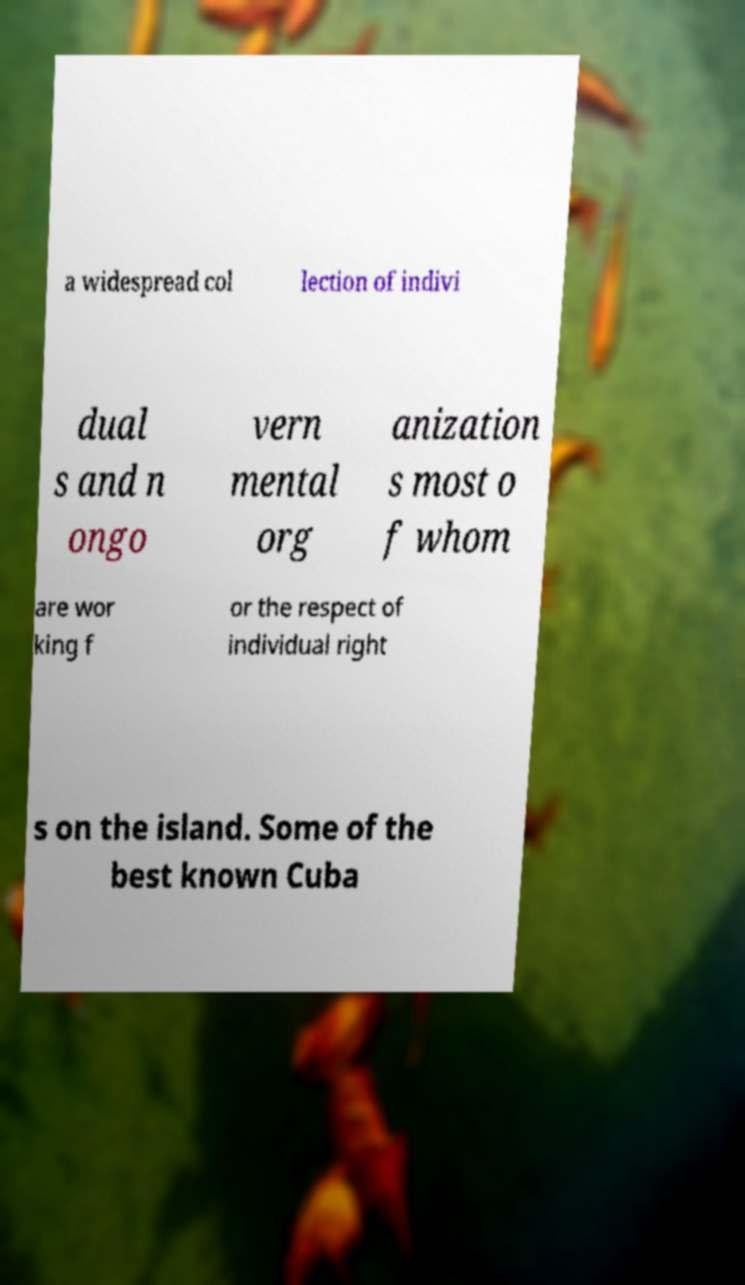What messages or text are displayed in this image? I need them in a readable, typed format. a widespread col lection of indivi dual s and n ongo vern mental org anization s most o f whom are wor king f or the respect of individual right s on the island. Some of the best known Cuba 